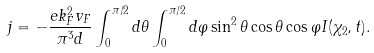Convert formula to latex. <formula><loc_0><loc_0><loc_500><loc_500>j = - \frac { e k _ { F } ^ { 2 } v _ { F } } { \pi ^ { 3 } d } \int _ { 0 } ^ { \pi / 2 } d \theta \int _ { 0 } ^ { \pi / 2 } d \varphi \sin ^ { 2 } \theta \cos \theta \cos \varphi I ( \chi _ { 2 } , t ) .</formula> 